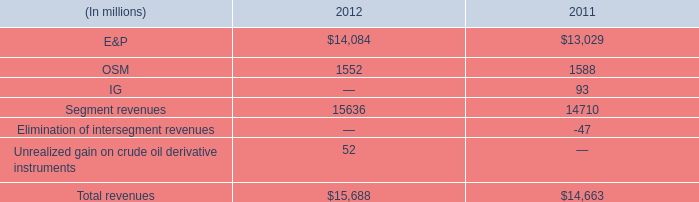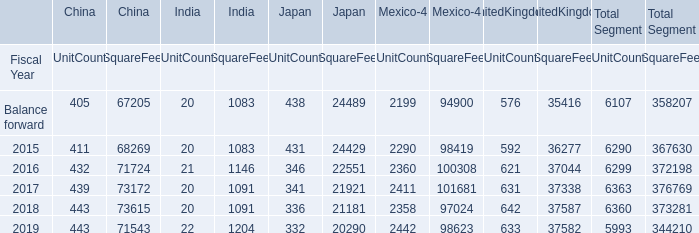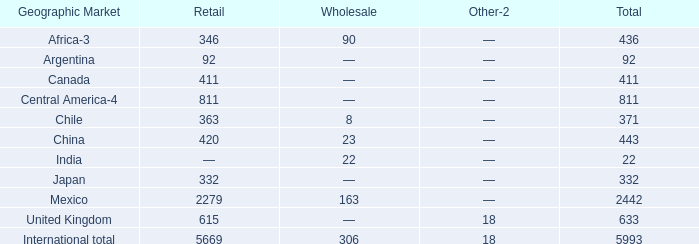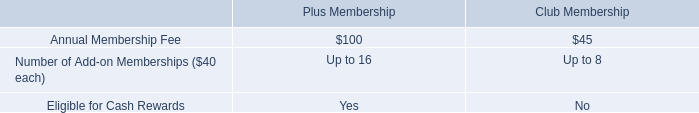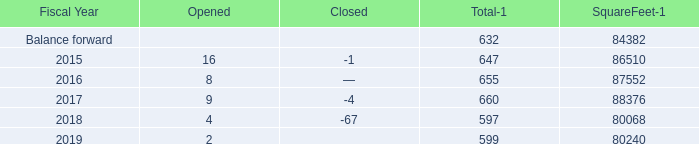What was the average value of the SquareFeet for Japan in the years where UnitCoun is positive for China? 
Computations: (((((24429 + 22551) + 21921) + 21181) + 20290) / 5)
Answer: 22074.4. 